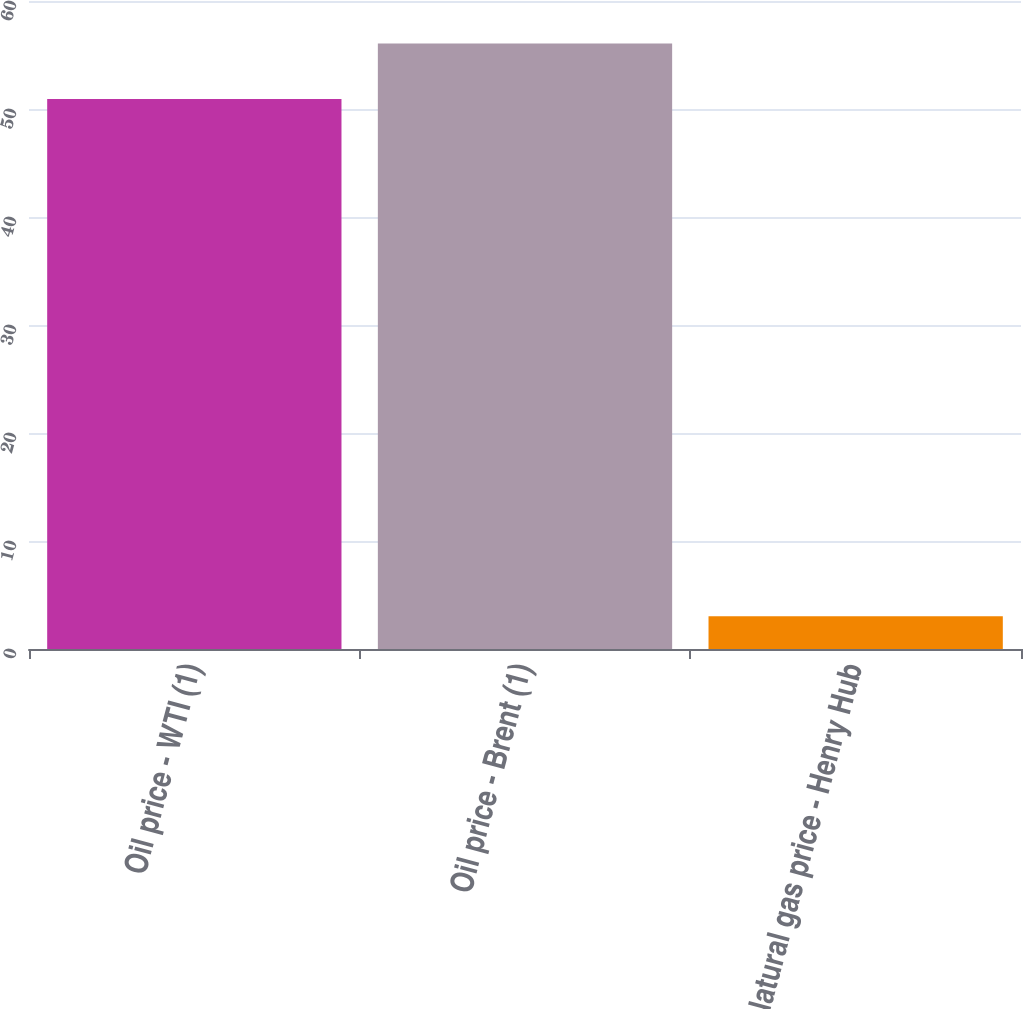<chart> <loc_0><loc_0><loc_500><loc_500><bar_chart><fcel>Oil price - WTI (1)<fcel>Oil price - Brent (1)<fcel>Natural gas price - Henry Hub<nl><fcel>50.93<fcel>56.06<fcel>3.04<nl></chart> 